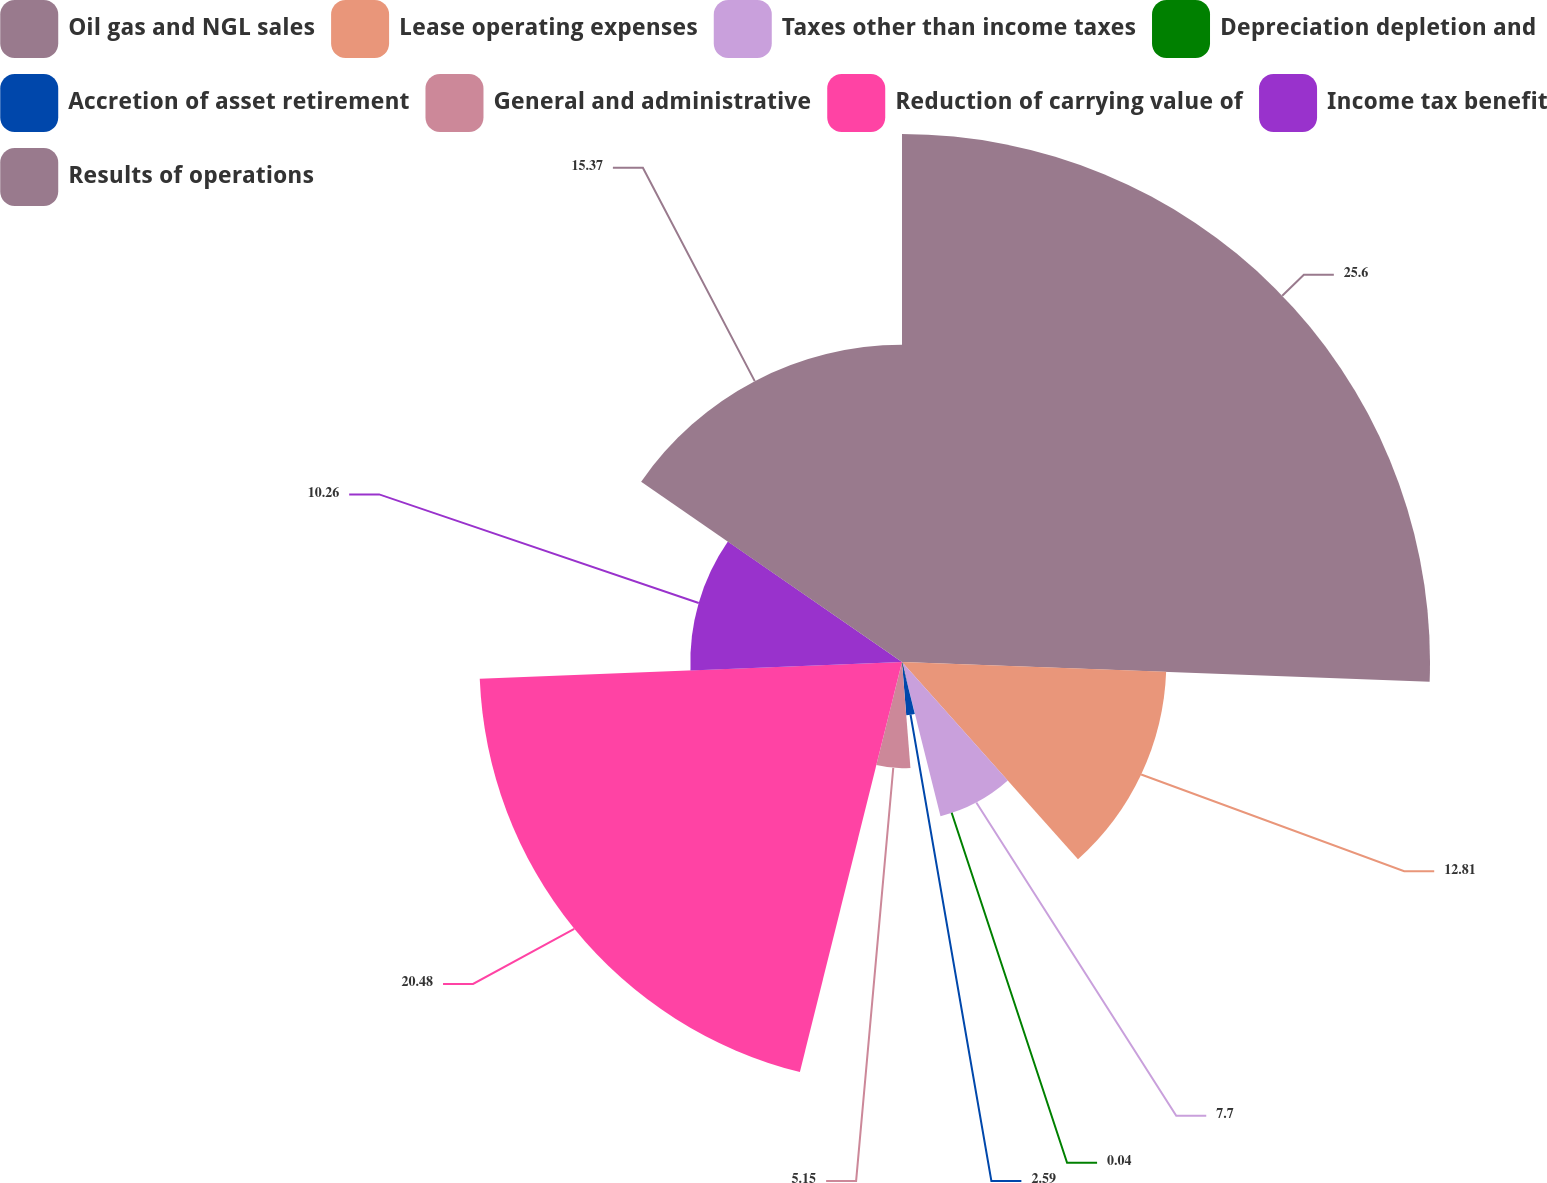<chart> <loc_0><loc_0><loc_500><loc_500><pie_chart><fcel>Oil gas and NGL sales<fcel>Lease operating expenses<fcel>Taxes other than income taxes<fcel>Depreciation depletion and<fcel>Accretion of asset retirement<fcel>General and administrative<fcel>Reduction of carrying value of<fcel>Income tax benefit<fcel>Results of operations<nl><fcel>25.59%<fcel>12.81%<fcel>7.7%<fcel>0.04%<fcel>2.59%<fcel>5.15%<fcel>20.48%<fcel>10.26%<fcel>15.37%<nl></chart> 